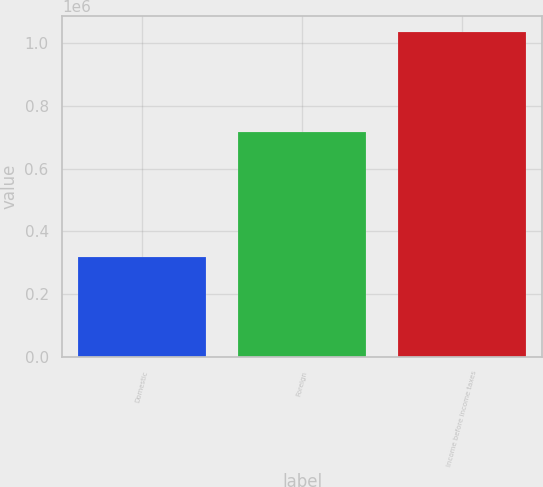Convert chart. <chart><loc_0><loc_0><loc_500><loc_500><bar_chart><fcel>Domestic<fcel>Foreign<fcel>Income before income taxes<nl><fcel>319500<fcel>715730<fcel>1.03523e+06<nl></chart> 